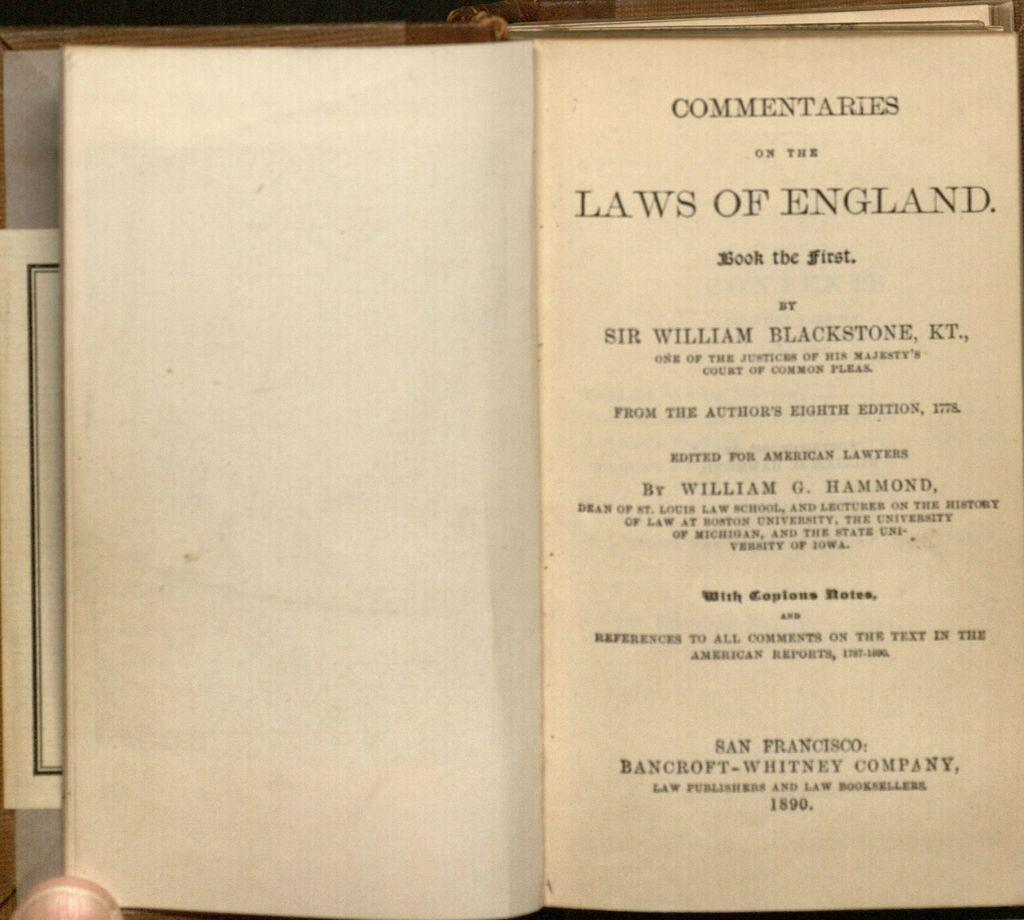<image>
Render a clear and concise summary of the photo. an open book to a page that says 'commentaries' on it 